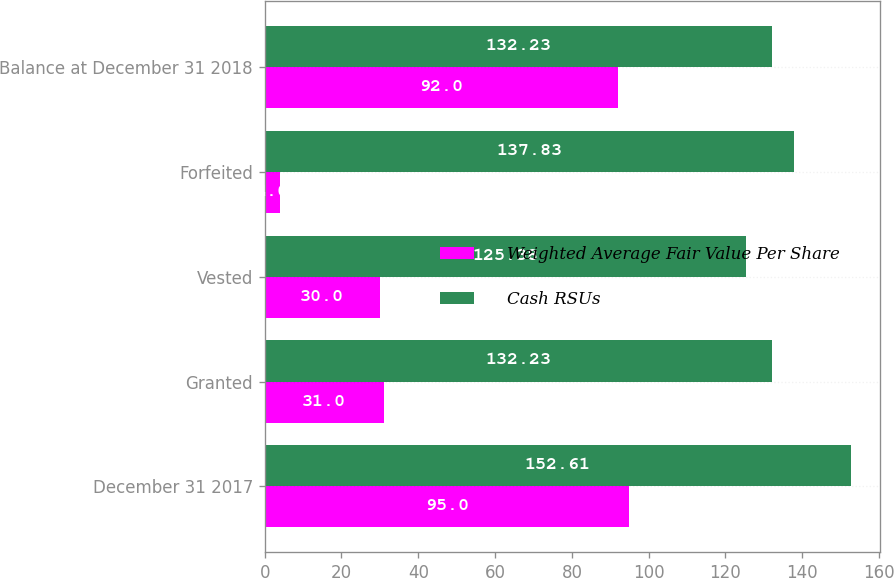<chart> <loc_0><loc_0><loc_500><loc_500><stacked_bar_chart><ecel><fcel>December 31 2017<fcel>Granted<fcel>Vested<fcel>Forfeited<fcel>Balance at December 31 2018<nl><fcel>Weighted Average Fair Value Per Share<fcel>95<fcel>31<fcel>30<fcel>4<fcel>92<nl><fcel>Cash RSUs<fcel>152.61<fcel>132.23<fcel>125.38<fcel>137.83<fcel>132.23<nl></chart> 